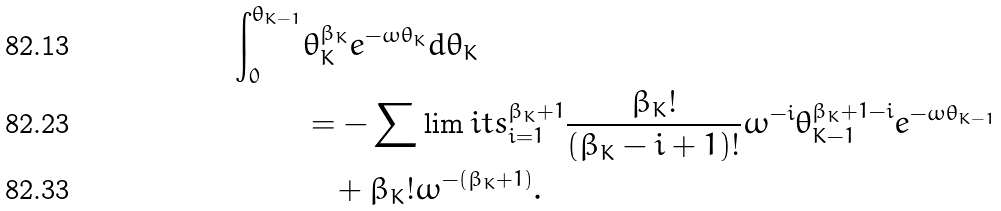Convert formula to latex. <formula><loc_0><loc_0><loc_500><loc_500>\int _ { 0 } ^ { \theta _ { K - 1 } } & \theta _ { K } ^ { \beta _ { K } } e ^ { - \omega \theta _ { K } } d \theta _ { K } \\ & = - \sum \lim i t s _ { i = 1 } ^ { \beta _ { K } + 1 } \frac { \beta _ { K } ! } { ( \beta _ { K } - i + 1 ) ! } \omega ^ { - i } \theta _ { K - 1 } ^ { \beta _ { K } + 1 - i } e ^ { - \omega \theta _ { K - 1 } } \\ & \quad + \beta _ { K } ! \omega ^ { - ( \beta _ { K } + 1 ) } .</formula> 